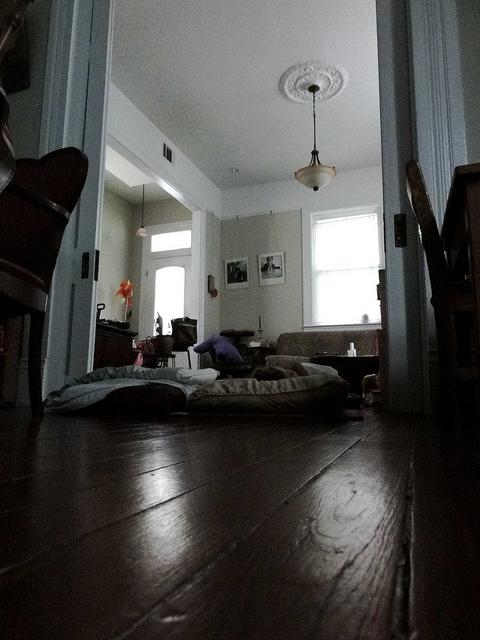Does this house look renovated?
Concise answer only. Yes. How would a person keep this floor shiny?
Short answer required. Wax. Is this a kitchen?
Be succinct. No. What is the floor made of?
Be succinct. Wood. Are these new hardwood floors?
Write a very short answer. No. Is this a shopping mall?
Keep it brief. No. How many pictures are hanging on the wall?
Be succinct. 2. 